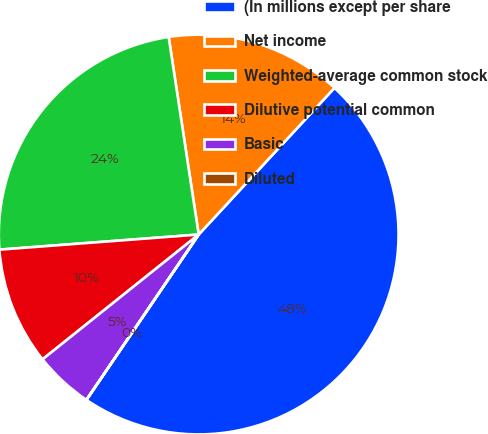<chart> <loc_0><loc_0><loc_500><loc_500><pie_chart><fcel>(In millions except per share<fcel>Net income<fcel>Weighted-average common stock<fcel>Dilutive potential common<fcel>Basic<fcel>Diluted<nl><fcel>47.61%<fcel>14.29%<fcel>23.81%<fcel>9.53%<fcel>4.77%<fcel>0.01%<nl></chart> 